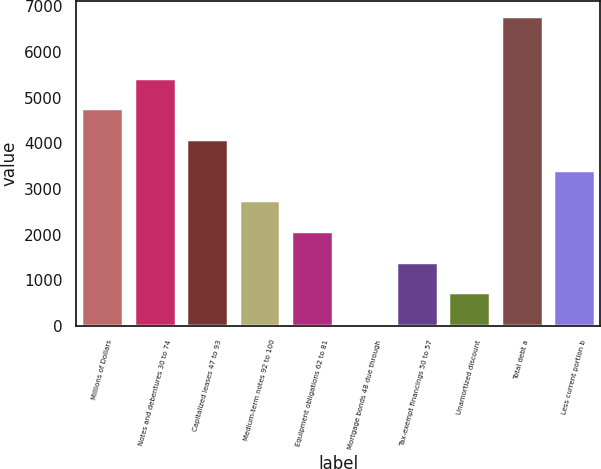Convert chart to OTSL. <chart><loc_0><loc_0><loc_500><loc_500><bar_chart><fcel>Millions of Dollars<fcel>Notes and debentures 30 to 74<fcel>Capitalized leases 47 to 93<fcel>Medium-term notes 92 to 100<fcel>Equipment obligations 62 to 81<fcel>Mortgage bonds 48 due through<fcel>Tax-exempt financings 50 to 57<fcel>Unamortized discount<fcel>Total debt a<fcel>Less current portion b<nl><fcel>4763.7<fcel>5435.8<fcel>4091.6<fcel>2747.4<fcel>2075.3<fcel>59<fcel>1403.2<fcel>731.1<fcel>6780<fcel>3419.5<nl></chart> 